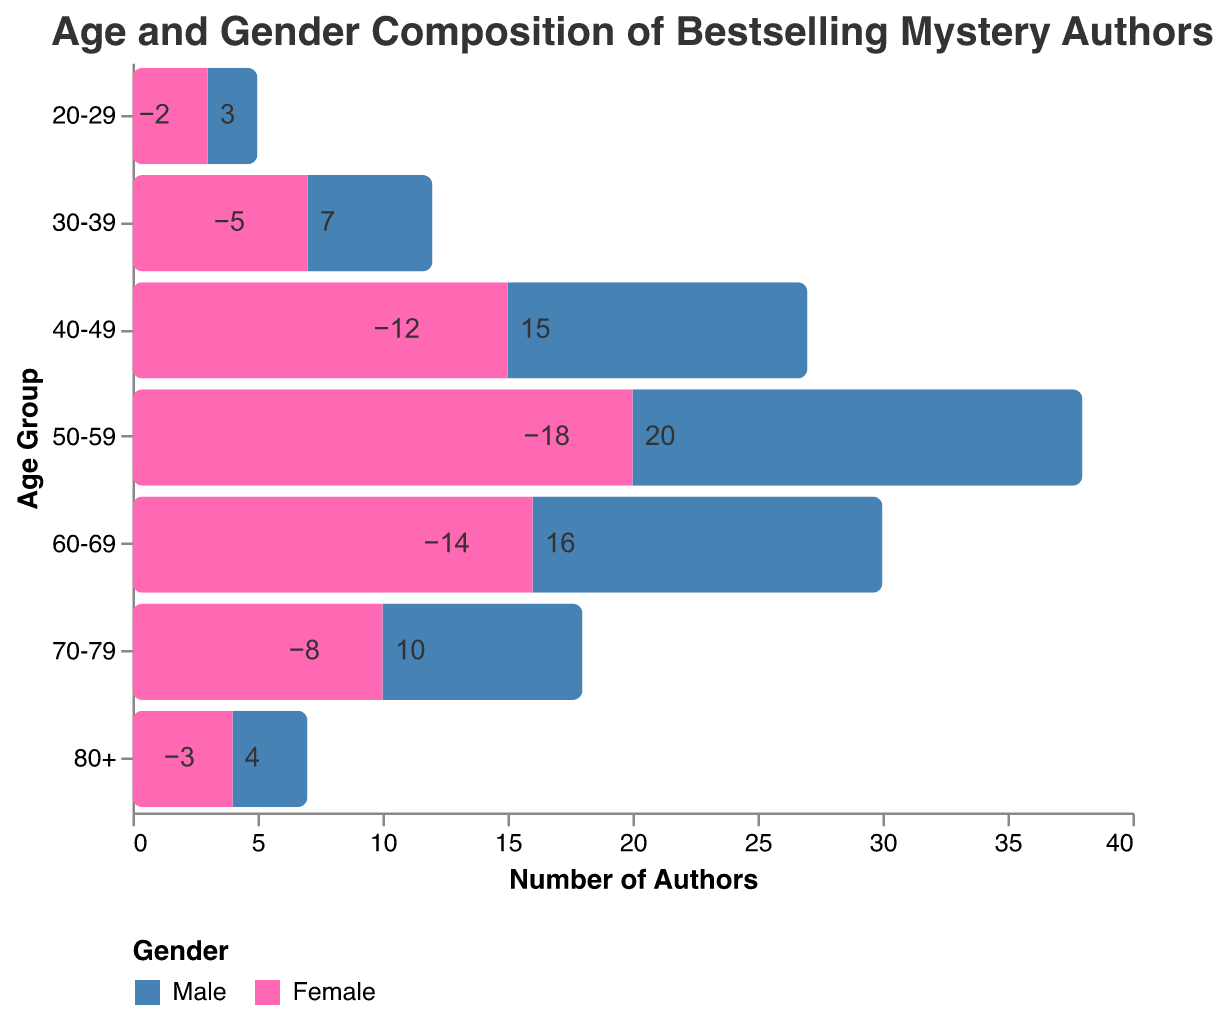What is the title of the figure? The title of the figure is provided at the top and gives an overview of what the figure represents.
Answer: Age and Gender Composition of Bestselling Mystery Authors Which age group has the highest number of female bestselling mystery authors? By observing the bars corresponding to the female gender, the age group with the longest bar is identified.
Answer: 50-59 What's the total number of bestselling male authors in the 50-59 age group? The bar for male authors in the 50-59 age group extends to the left, indicating negative values. The absolute value of this bar gives the number of authors.
Answer: 18 Do male or female authors dominate the 40-49 age group? Comparing the bars for males and females in this age group, the longer bar indicates the gender with more authors.
Answer: Female Which age group has the smallest difference in the number of male and female authors? For each age group, calculate the absolute difference between the male and female authors and identify the minimum difference.
Answer: 80+ In which age group is the gender disparity the greatest? Calculate the absolute differences between the counts of male and female authors for each age group and identify the group with the largest difference.
Answer: 50-59 How are the colors used in the figure to differentiate between genders? Observe the color legend and the bars in the figure to determine which colors represent each gender.
Answer: Blue for male, Pink for female 